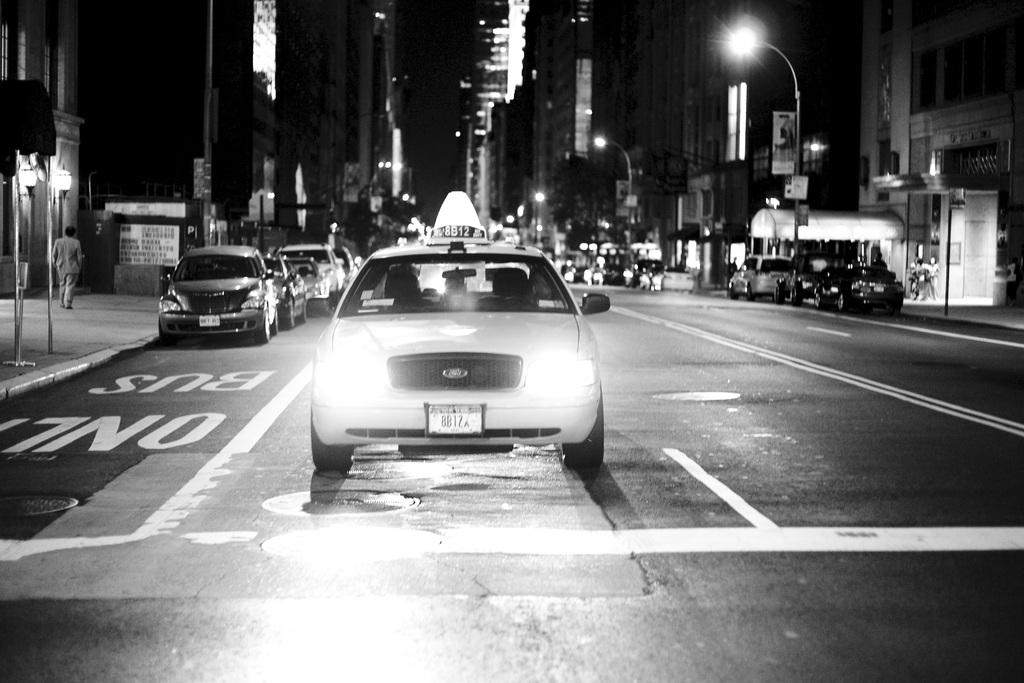What is at the bottom of the image? There is a road at the bottom of the image. What is happening on the road? Cars are present on the road. Can you describe the man on the left side of the image? There is a man walking on the left side of the image. What can be seen in the background of the image? There are buildings and poles in the background of the image. What else is visible in the image? Lights are visible in the image. What type of thing is being recited in verse in the image? There is no indication of any recitation or verse in the image; it primarily features a road, cars, a man walking, buildings, poles, and lights. What is the plot of the story unfolding in the image? There is no story or plot depicted in the image; it is a scene of a road, cars, a man walking, buildings, poles, and lights. 